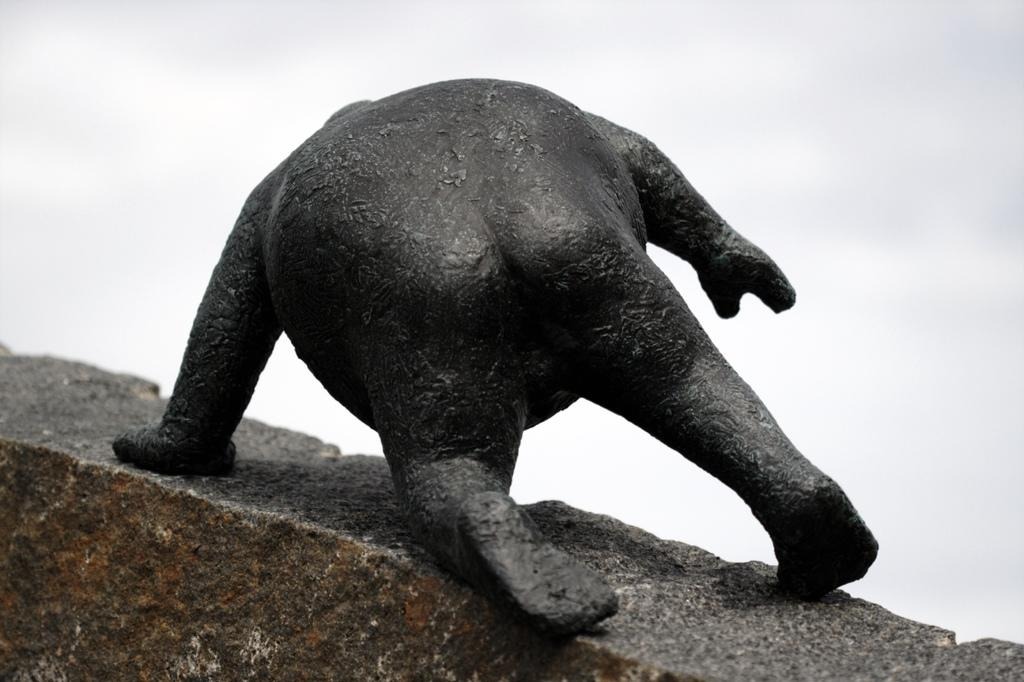What type of creature is in the image? There is an animal in the image. Where is the animal located? The animal is on a stone. What can be seen in the background of the image? The sky is visible in the background of the image. How would you describe the sky in the image? The sky appears cloudy. What type of chain is the doctor holding in the image? There is no chain or doctor present in the image; it features an animal on a stone with a cloudy sky in the background. 